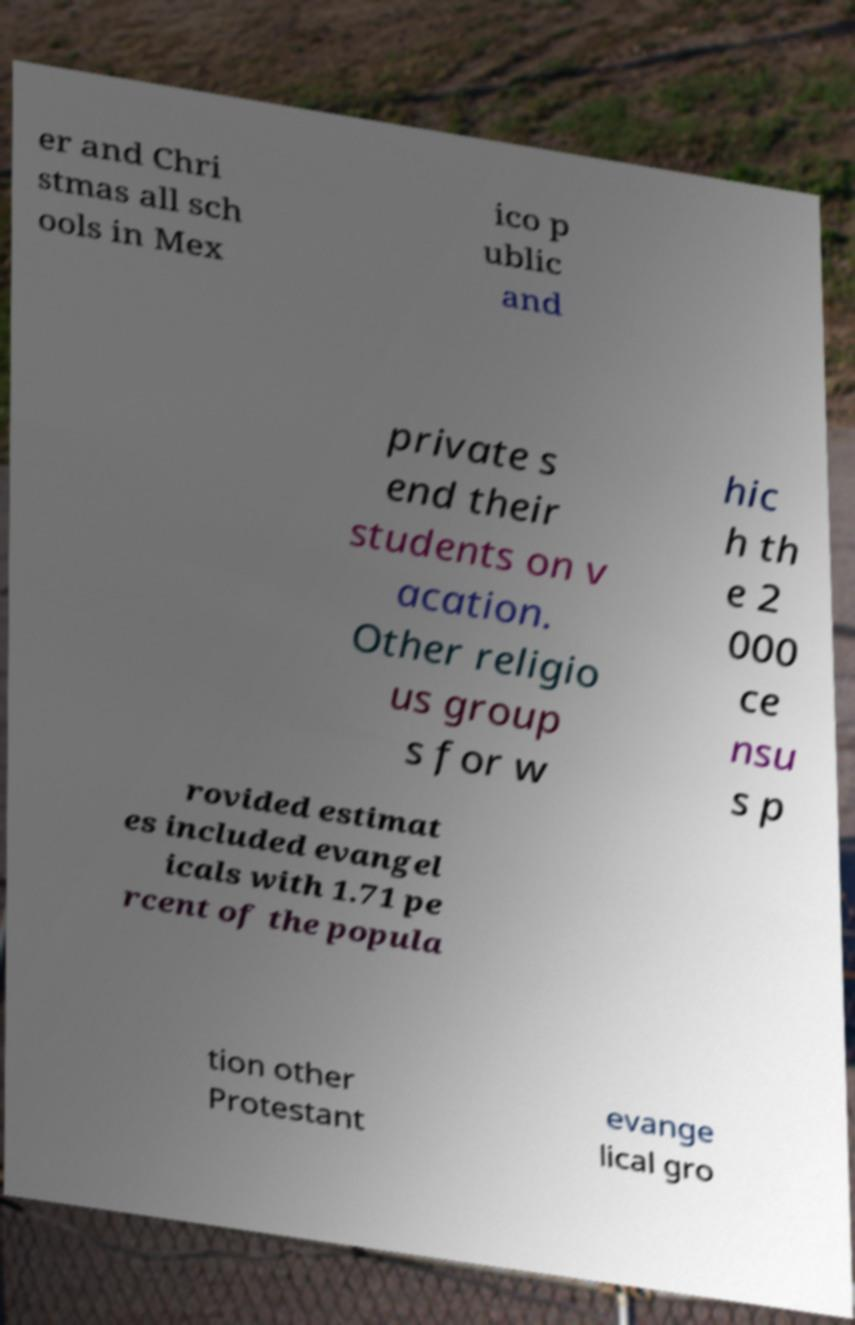Could you extract and type out the text from this image? er and Chri stmas all sch ools in Mex ico p ublic and private s end their students on v acation. Other religio us group s for w hic h th e 2 000 ce nsu s p rovided estimat es included evangel icals with 1.71 pe rcent of the popula tion other Protestant evange lical gro 